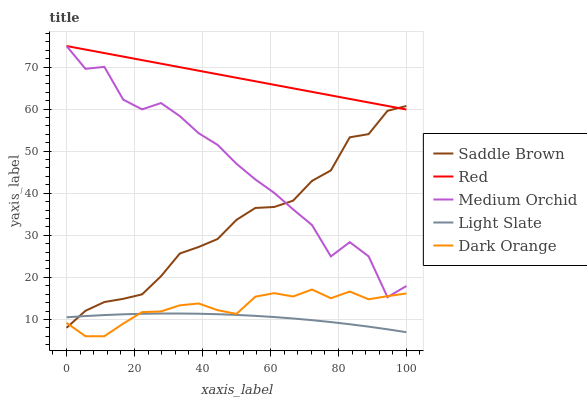Does Light Slate have the minimum area under the curve?
Answer yes or no. Yes. Does Red have the maximum area under the curve?
Answer yes or no. Yes. Does Dark Orange have the minimum area under the curve?
Answer yes or no. No. Does Dark Orange have the maximum area under the curve?
Answer yes or no. No. Is Red the smoothest?
Answer yes or no. Yes. Is Medium Orchid the roughest?
Answer yes or no. Yes. Is Dark Orange the smoothest?
Answer yes or no. No. Is Dark Orange the roughest?
Answer yes or no. No. Does Dark Orange have the lowest value?
Answer yes or no. Yes. Does Medium Orchid have the lowest value?
Answer yes or no. No. Does Red have the highest value?
Answer yes or no. Yes. Does Dark Orange have the highest value?
Answer yes or no. No. Is Dark Orange less than Red?
Answer yes or no. Yes. Is Red greater than Dark Orange?
Answer yes or no. Yes. Does Dark Orange intersect Saddle Brown?
Answer yes or no. Yes. Is Dark Orange less than Saddle Brown?
Answer yes or no. No. Is Dark Orange greater than Saddle Brown?
Answer yes or no. No. Does Dark Orange intersect Red?
Answer yes or no. No. 